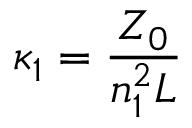Convert formula to latex. <formula><loc_0><loc_0><loc_500><loc_500>\kappa _ { 1 } = \frac { Z _ { 0 } } { n _ { 1 } ^ { 2 } L }</formula> 